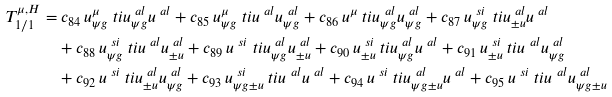Convert formula to latex. <formula><loc_0><loc_0><loc_500><loc_500>T _ { 1 / 1 } ^ { \mu , H } = & \ c _ { 8 4 } \, u ^ { \mu } _ { \psi g } \ t i { u } ^ { \ a l } _ { \psi g } u ^ { \ a l } + c _ { 8 5 } \, u ^ { \mu } _ { \psi g } \ t i { u } ^ { \ a l } u ^ { \ a l } _ { \psi g } + c _ { 8 6 } \, u ^ { \mu } \ t i { u } ^ { \ a l } _ { \psi g } u ^ { \ a l } _ { \psi g } + c _ { 8 7 } \, u ^ { \ s i } _ { \psi g } \ t i { u } ^ { \ a l } _ { \pm u } u ^ { \ a l } \\ & + c _ { 8 8 } \, u ^ { \ s i } _ { \psi g } \ t i { u } ^ { \ a l } u ^ { \ a l } _ { \pm u } + c _ { 8 9 } \, u ^ { \ s i } \ t i { u } ^ { \ a l } _ { \psi g } u ^ { \ a l } _ { \pm u } + c _ { 9 0 } \, u ^ { \ s i } _ { \pm u } \ t i { u } ^ { \ a l } _ { \psi g } u ^ { \ a l } + c _ { 9 1 } \, u ^ { \ s i } _ { \pm u } \ t i { u } ^ { \ a l } u ^ { \ a l } _ { \psi g } \\ & + c _ { 9 2 } \, u ^ { \ s i } \ t i { u } ^ { \ a l } _ { \pm u } u ^ { \ a l } _ { \psi g } + c _ { 9 3 } \, u ^ { \ s i } _ { \psi g \pm u } \ t i { u } ^ { \ a l } u ^ { \ a l } + c _ { 9 4 } \, u ^ { \ s i } \ t i { u } ^ { \ a l } _ { \psi g \pm u } u ^ { \ a l } + c _ { 9 5 } \, u ^ { \ s i } \ t i { u } ^ { \ a l } u ^ { \ a l } _ { \psi g \pm u } \\</formula> 